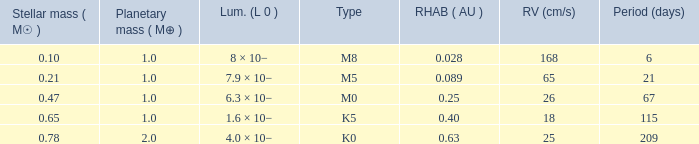21, and of the m0 category? 67.0. 